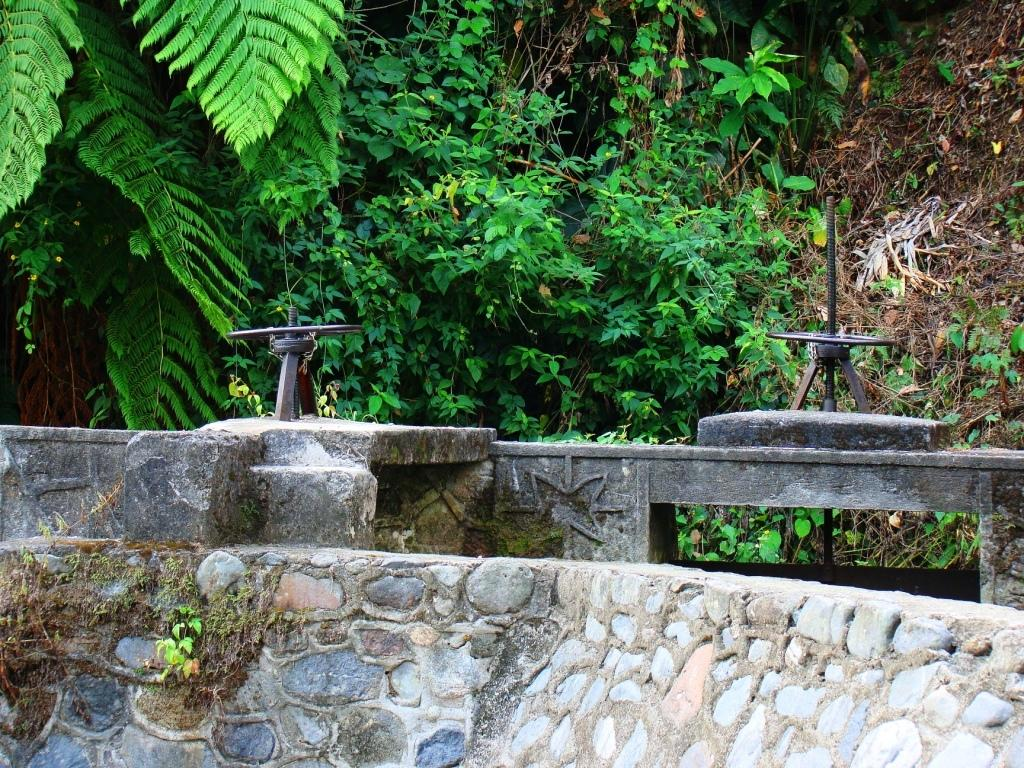What type of device is present on the wall in the image? There are rain water sprinklers on the wall in the image. What is the purpose of these devices? The rain water sprinklers are likely used for watering plants. What types of vegetation can be seen in the image? There are plants and trees visible in the image. What alley is visible in the image? There is no alley present in the image. What hobbies are the plants and trees engaged in within the image? Plants and trees do not have hobbies; they are living organisms that grow and provide oxygen. 